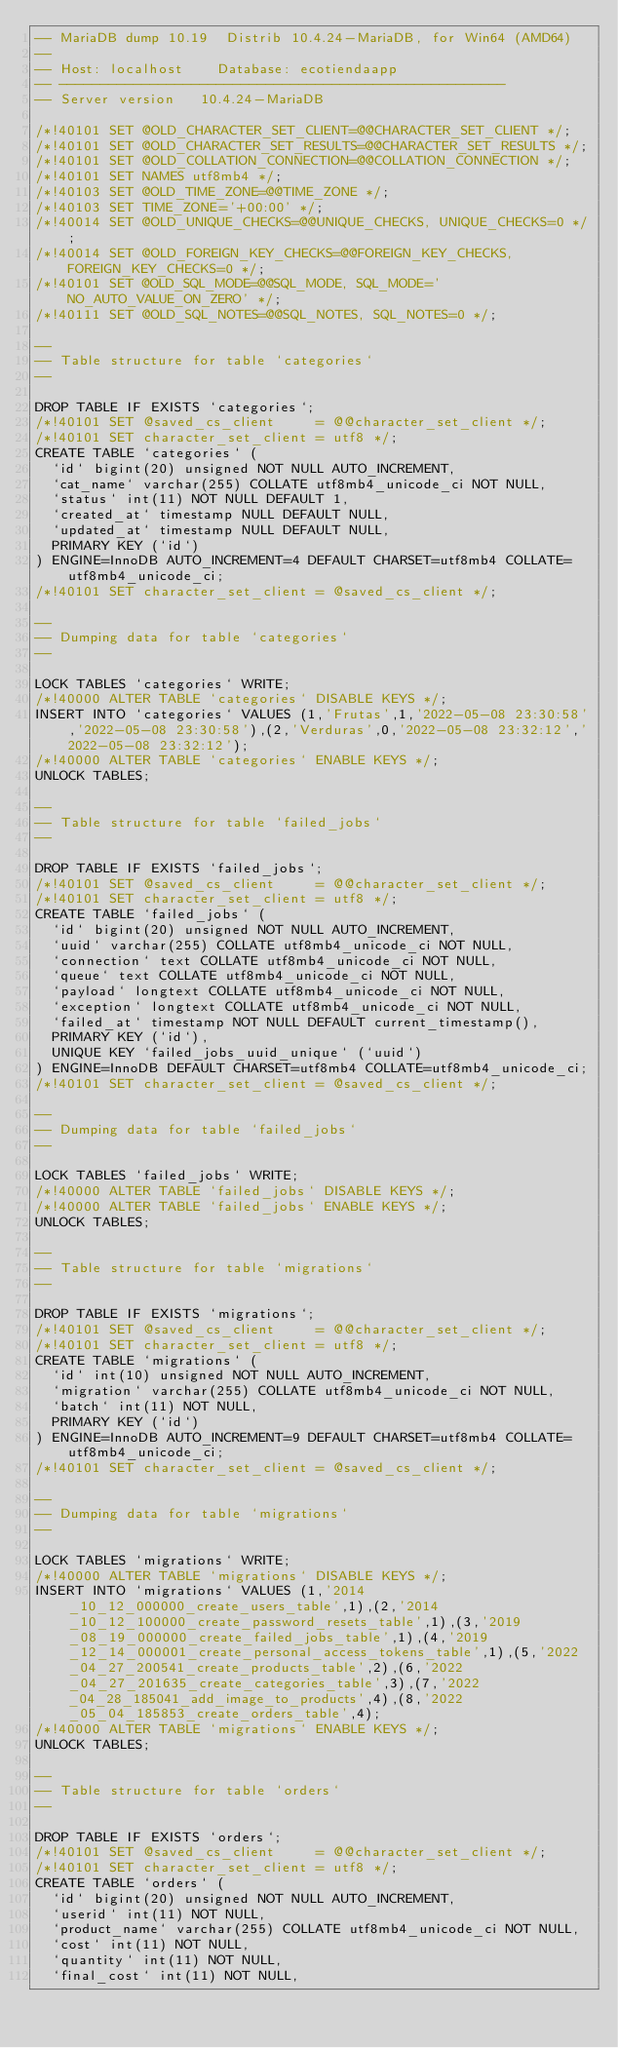<code> <loc_0><loc_0><loc_500><loc_500><_SQL_>-- MariaDB dump 10.19  Distrib 10.4.24-MariaDB, for Win64 (AMD64)
--
-- Host: localhost    Database: ecotiendaapp
-- ------------------------------------------------------
-- Server version	10.4.24-MariaDB

/*!40101 SET @OLD_CHARACTER_SET_CLIENT=@@CHARACTER_SET_CLIENT */;
/*!40101 SET @OLD_CHARACTER_SET_RESULTS=@@CHARACTER_SET_RESULTS */;
/*!40101 SET @OLD_COLLATION_CONNECTION=@@COLLATION_CONNECTION */;
/*!40101 SET NAMES utf8mb4 */;
/*!40103 SET @OLD_TIME_ZONE=@@TIME_ZONE */;
/*!40103 SET TIME_ZONE='+00:00' */;
/*!40014 SET @OLD_UNIQUE_CHECKS=@@UNIQUE_CHECKS, UNIQUE_CHECKS=0 */;
/*!40014 SET @OLD_FOREIGN_KEY_CHECKS=@@FOREIGN_KEY_CHECKS, FOREIGN_KEY_CHECKS=0 */;
/*!40101 SET @OLD_SQL_MODE=@@SQL_MODE, SQL_MODE='NO_AUTO_VALUE_ON_ZERO' */;
/*!40111 SET @OLD_SQL_NOTES=@@SQL_NOTES, SQL_NOTES=0 */;

--
-- Table structure for table `categories`
--

DROP TABLE IF EXISTS `categories`;
/*!40101 SET @saved_cs_client     = @@character_set_client */;
/*!40101 SET character_set_client = utf8 */;
CREATE TABLE `categories` (
  `id` bigint(20) unsigned NOT NULL AUTO_INCREMENT,
  `cat_name` varchar(255) COLLATE utf8mb4_unicode_ci NOT NULL,
  `status` int(11) NOT NULL DEFAULT 1,
  `created_at` timestamp NULL DEFAULT NULL,
  `updated_at` timestamp NULL DEFAULT NULL,
  PRIMARY KEY (`id`)
) ENGINE=InnoDB AUTO_INCREMENT=4 DEFAULT CHARSET=utf8mb4 COLLATE=utf8mb4_unicode_ci;
/*!40101 SET character_set_client = @saved_cs_client */;

--
-- Dumping data for table `categories`
--

LOCK TABLES `categories` WRITE;
/*!40000 ALTER TABLE `categories` DISABLE KEYS */;
INSERT INTO `categories` VALUES (1,'Frutas',1,'2022-05-08 23:30:58','2022-05-08 23:30:58'),(2,'Verduras',0,'2022-05-08 23:32:12','2022-05-08 23:32:12');
/*!40000 ALTER TABLE `categories` ENABLE KEYS */;
UNLOCK TABLES;

--
-- Table structure for table `failed_jobs`
--

DROP TABLE IF EXISTS `failed_jobs`;
/*!40101 SET @saved_cs_client     = @@character_set_client */;
/*!40101 SET character_set_client = utf8 */;
CREATE TABLE `failed_jobs` (
  `id` bigint(20) unsigned NOT NULL AUTO_INCREMENT,
  `uuid` varchar(255) COLLATE utf8mb4_unicode_ci NOT NULL,
  `connection` text COLLATE utf8mb4_unicode_ci NOT NULL,
  `queue` text COLLATE utf8mb4_unicode_ci NOT NULL,
  `payload` longtext COLLATE utf8mb4_unicode_ci NOT NULL,
  `exception` longtext COLLATE utf8mb4_unicode_ci NOT NULL,
  `failed_at` timestamp NOT NULL DEFAULT current_timestamp(),
  PRIMARY KEY (`id`),
  UNIQUE KEY `failed_jobs_uuid_unique` (`uuid`)
) ENGINE=InnoDB DEFAULT CHARSET=utf8mb4 COLLATE=utf8mb4_unicode_ci;
/*!40101 SET character_set_client = @saved_cs_client */;

--
-- Dumping data for table `failed_jobs`
--

LOCK TABLES `failed_jobs` WRITE;
/*!40000 ALTER TABLE `failed_jobs` DISABLE KEYS */;
/*!40000 ALTER TABLE `failed_jobs` ENABLE KEYS */;
UNLOCK TABLES;

--
-- Table structure for table `migrations`
--

DROP TABLE IF EXISTS `migrations`;
/*!40101 SET @saved_cs_client     = @@character_set_client */;
/*!40101 SET character_set_client = utf8 */;
CREATE TABLE `migrations` (
  `id` int(10) unsigned NOT NULL AUTO_INCREMENT,
  `migration` varchar(255) COLLATE utf8mb4_unicode_ci NOT NULL,
  `batch` int(11) NOT NULL,
  PRIMARY KEY (`id`)
) ENGINE=InnoDB AUTO_INCREMENT=9 DEFAULT CHARSET=utf8mb4 COLLATE=utf8mb4_unicode_ci;
/*!40101 SET character_set_client = @saved_cs_client */;

--
-- Dumping data for table `migrations`
--

LOCK TABLES `migrations` WRITE;
/*!40000 ALTER TABLE `migrations` DISABLE KEYS */;
INSERT INTO `migrations` VALUES (1,'2014_10_12_000000_create_users_table',1),(2,'2014_10_12_100000_create_password_resets_table',1),(3,'2019_08_19_000000_create_failed_jobs_table',1),(4,'2019_12_14_000001_create_personal_access_tokens_table',1),(5,'2022_04_27_200541_create_products_table',2),(6,'2022_04_27_201635_create_categories_table',3),(7,'2022_04_28_185041_add_image_to_products',4),(8,'2022_05_04_185853_create_orders_table',4);
/*!40000 ALTER TABLE `migrations` ENABLE KEYS */;
UNLOCK TABLES;

--
-- Table structure for table `orders`
--

DROP TABLE IF EXISTS `orders`;
/*!40101 SET @saved_cs_client     = @@character_set_client */;
/*!40101 SET character_set_client = utf8 */;
CREATE TABLE `orders` (
  `id` bigint(20) unsigned NOT NULL AUTO_INCREMENT,
  `userid` int(11) NOT NULL,
  `product_name` varchar(255) COLLATE utf8mb4_unicode_ci NOT NULL,
  `cost` int(11) NOT NULL,
  `quantity` int(11) NOT NULL,
  `final_cost` int(11) NOT NULL,</code> 